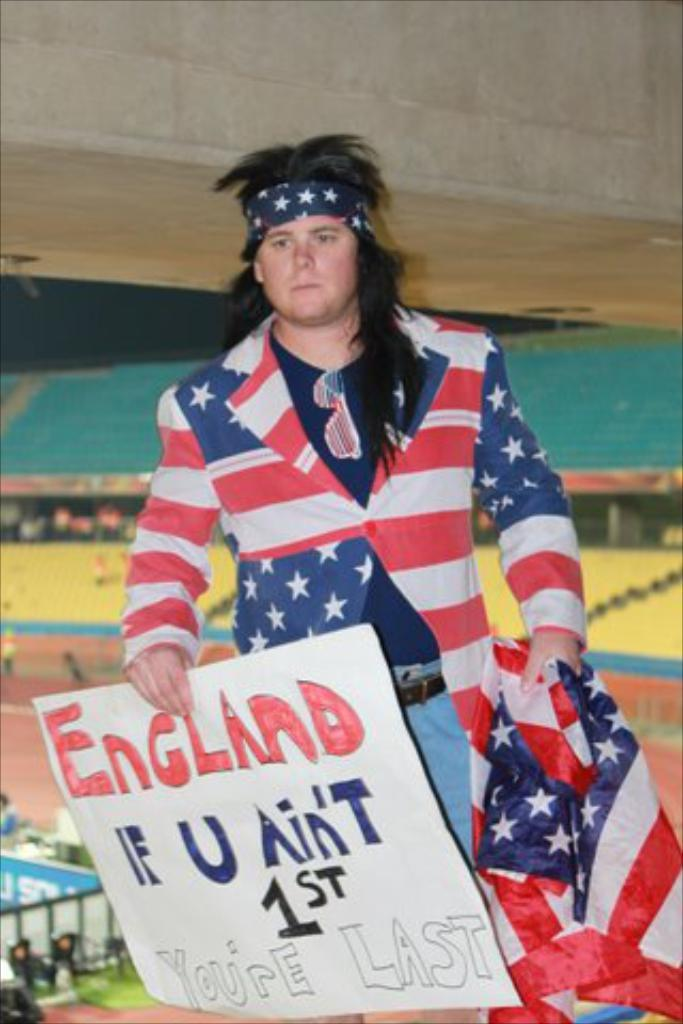<image>
Create a compact narrative representing the image presented. A man wearing a Stars and Shirts suit holding a sign with the word England on the top. 